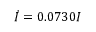<formula> <loc_0><loc_0><loc_500><loc_500>\dot { I } = 0 . 0 7 3 0 I</formula> 